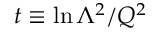Convert formula to latex. <formula><loc_0><loc_0><loc_500><loc_500>t \equiv \ln \Lambda ^ { 2 } / Q ^ { 2 }</formula> 